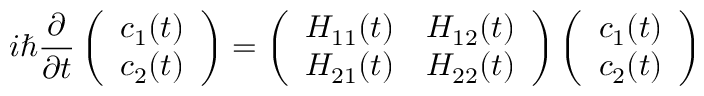<formula> <loc_0><loc_0><loc_500><loc_500>i \hbar { } \partial } { \partial t } \left ( \begin{array} { l } { c _ { 1 } ( t ) } \\ { c _ { 2 } ( t ) } \end{array} \right ) = \left ( \begin{array} { l l } { H _ { 1 1 } ( t ) } & { H _ { 1 2 } ( t ) } \\ { H _ { 2 1 } ( t ) } & { H _ { 2 2 } ( t ) } \end{array} \right ) \left ( \begin{array} { l } { c _ { 1 } ( t ) } \\ { c _ { 2 } ( t ) } \end{array} \right )</formula> 